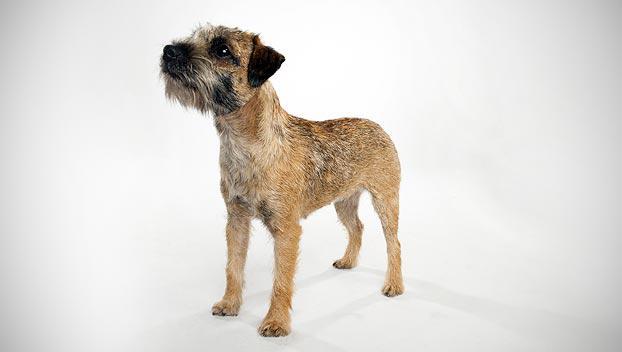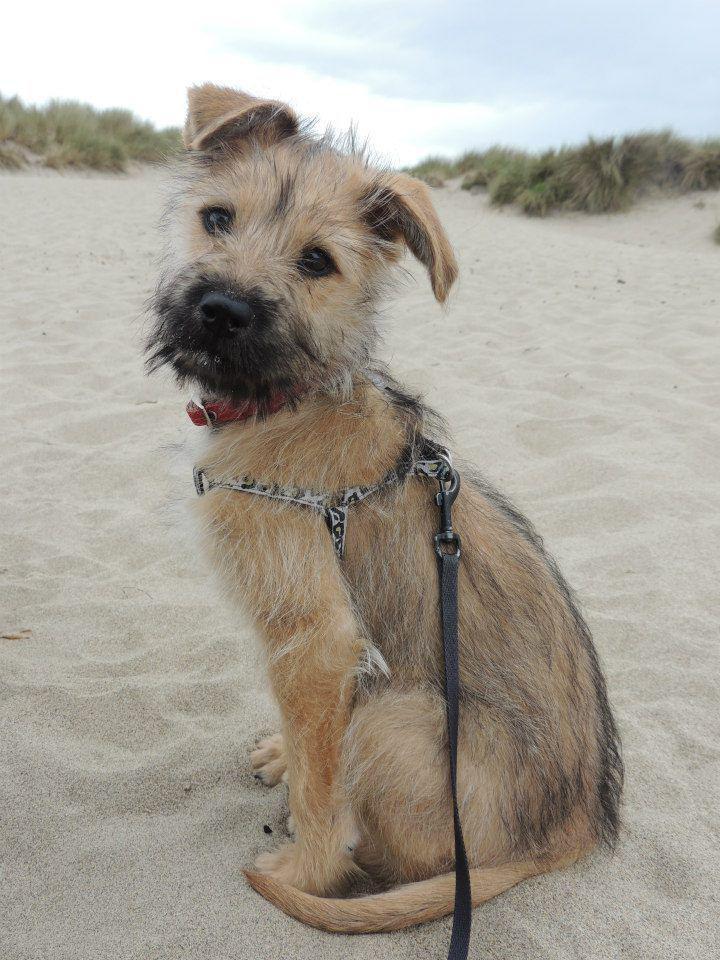The first image is the image on the left, the second image is the image on the right. For the images shown, is this caption "One dog has a collar or leash." true? Answer yes or no. Yes. The first image is the image on the left, the second image is the image on the right. Assess this claim about the two images: "One photo shows the full body of an adult dog against a plain white background.". Correct or not? Answer yes or no. Yes. 